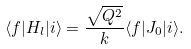<formula> <loc_0><loc_0><loc_500><loc_500>\langle f | H _ { l } | i \rangle = \frac { \sqrt { Q ^ { 2 } } } { k } \langle f | J _ { 0 } | i \rangle .</formula> 